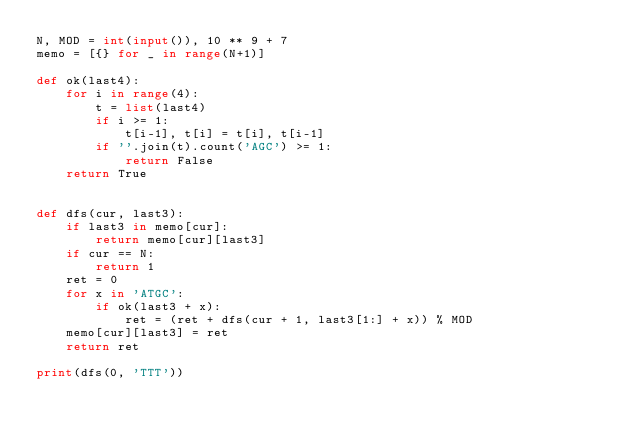<code> <loc_0><loc_0><loc_500><loc_500><_Python_>N, MOD = int(input()), 10 ** 9 + 7
memo = [{} for _ in range(N+1)]

def ok(last4):
    for i in range(4):
        t = list(last4)
        if i >= 1:
            t[i-1], t[i] = t[i], t[i-1]
        if ''.join(t).count('AGC') >= 1:
            return False
    return True


def dfs(cur, last3):
    if last3 in memo[cur]:
        return memo[cur][last3]
    if cur == N:
        return 1
    ret = 0
    for x in 'ATGC':
        if ok(last3 + x):
            ret = (ret + dfs(cur + 1, last3[1:] + x)) % MOD
    memo[cur][last3] = ret
    return ret

print(dfs(0, 'TTT'))
</code> 